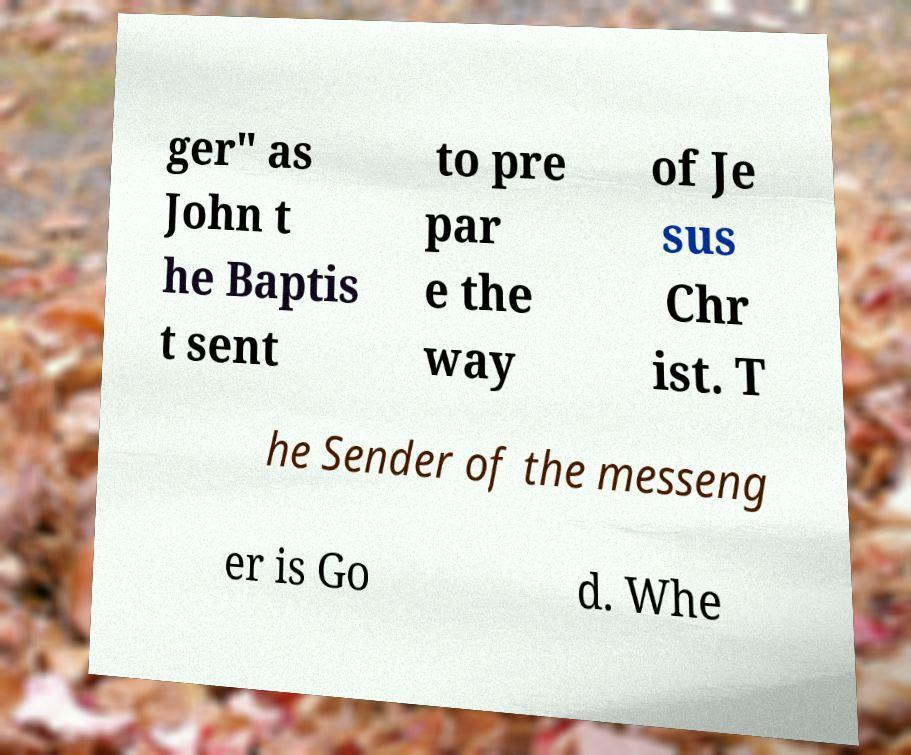Could you extract and type out the text from this image? ger" as John t he Baptis t sent to pre par e the way of Je sus Chr ist. T he Sender of the messeng er is Go d. Whe 